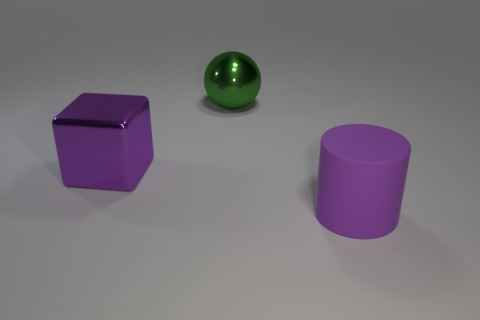Add 1 brown rubber balls. How many objects exist? 4 Add 2 green things. How many green things are left? 3 Add 2 big brown metallic things. How many big brown metallic things exist? 2 Subtract 1 purple blocks. How many objects are left? 2 Subtract all balls. How many objects are left? 2 Subtract all green spheres. How many green cubes are left? 0 Subtract all large green metallic things. Subtract all metal balls. How many objects are left? 1 